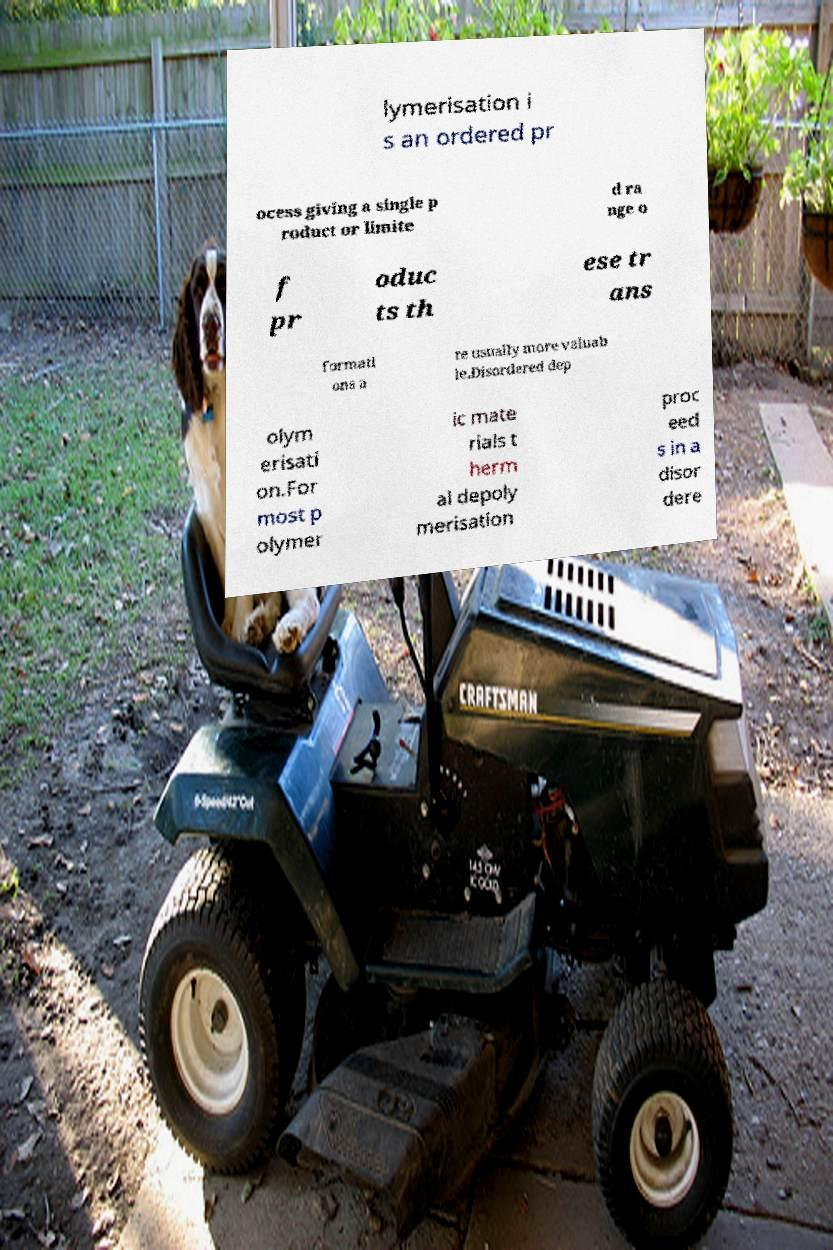Could you assist in decoding the text presented in this image and type it out clearly? lymerisation i s an ordered pr ocess giving a single p roduct or limite d ra nge o f pr oduc ts th ese tr ans formati ons a re usually more valuab le.Disordered dep olym erisati on.For most p olymer ic mate rials t herm al depoly merisation proc eed s in a disor dere 